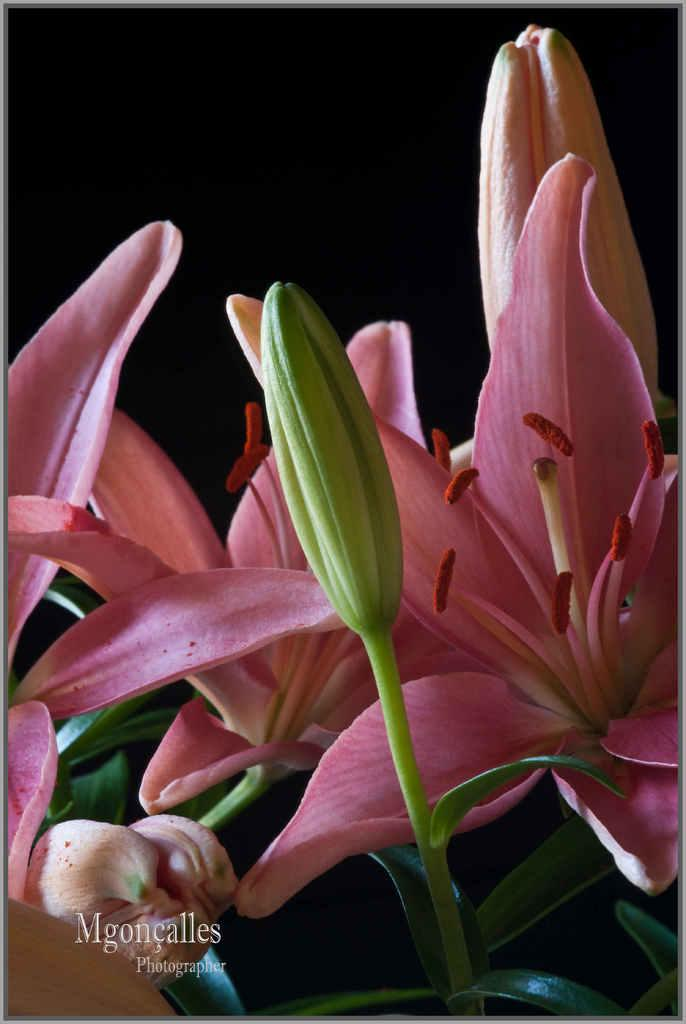What type of flowers can be seen in the image? There are beautiful pink flowers in the image. Can you describe the stage of development of one of the flowers? There is a flower bud in the image. What is the relationship between the flowers and the flower bud? Both elements are associated with a plant. Who is the creator of the chair in the image? There is no chair present in the image. 